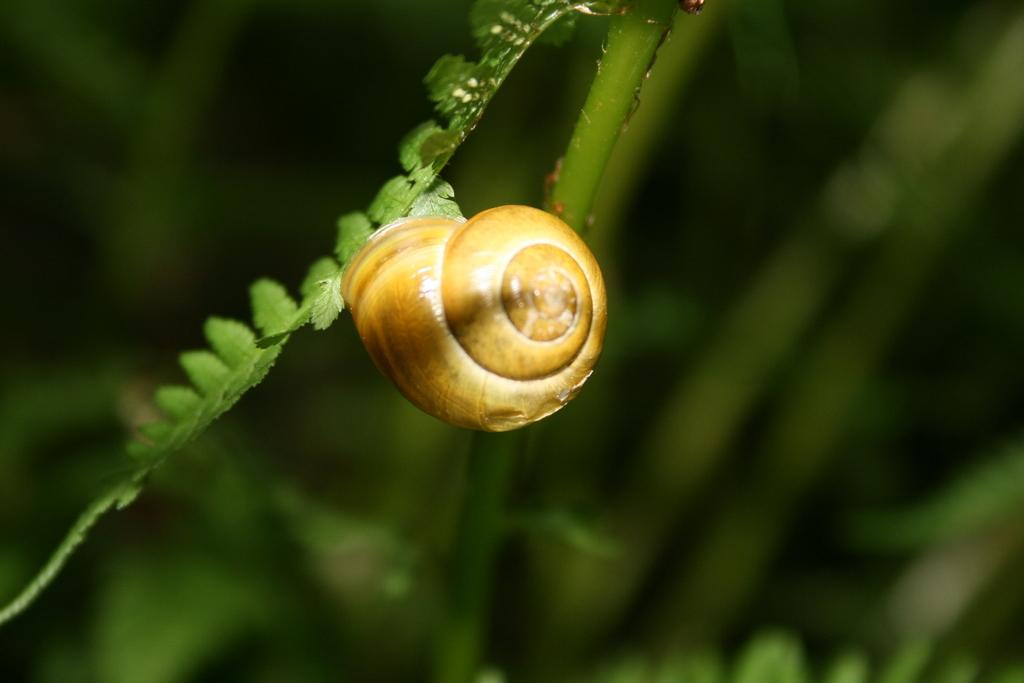What object can be seen in the image? There is a shell in the image. What is the color of the shell? The shell is brown in color. What other natural elements are present in the image? There are leaves of a plant in the image. How would you describe the background of the image? The background is green and blurred. What type of music can be heard playing in the background of the image? There is no music present in the image, as it is a still photograph of a shell and leaves. 